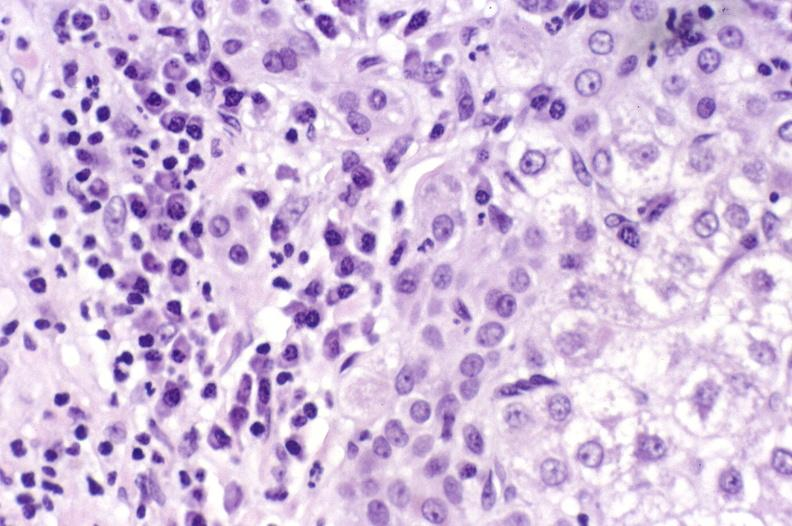s cysticercosis present?
Answer the question using a single word or phrase. No 